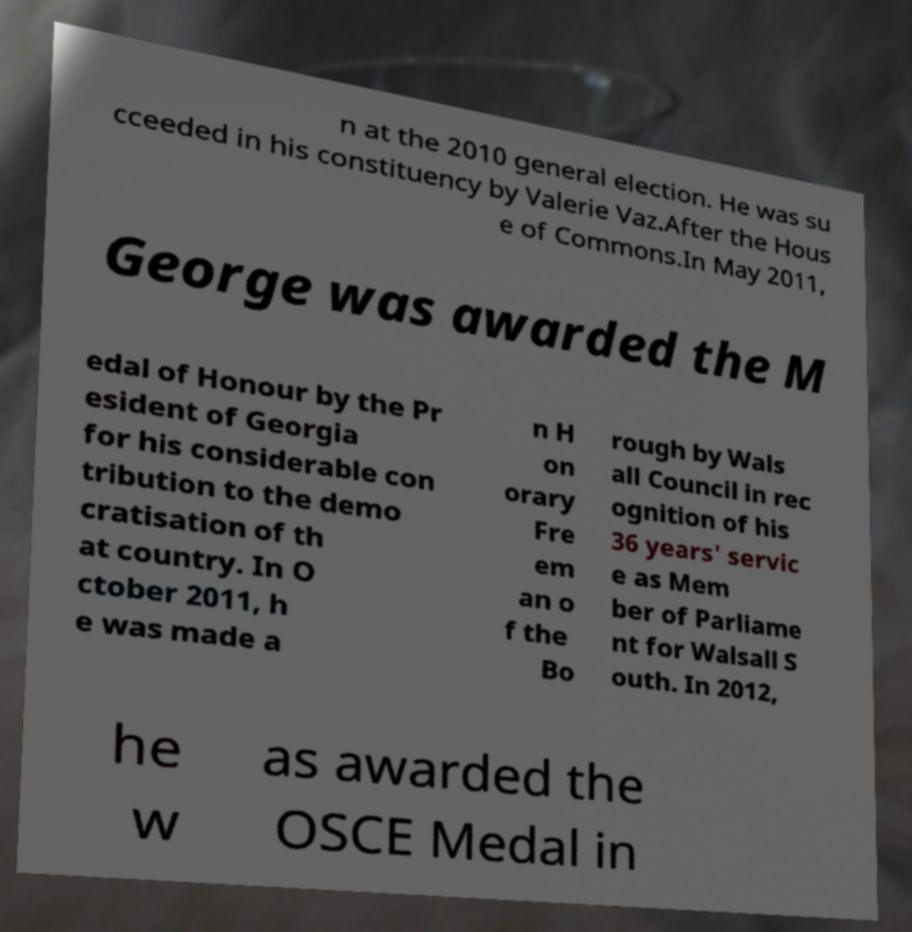There's text embedded in this image that I need extracted. Can you transcribe it verbatim? n at the 2010 general election. He was su cceeded in his constituency by Valerie Vaz.After the Hous e of Commons.In May 2011, George was awarded the M edal of Honour by the Pr esident of Georgia for his considerable con tribution to the demo cratisation of th at country. In O ctober 2011, h e was made a n H on orary Fre em an o f the Bo rough by Wals all Council in rec ognition of his 36 years' servic e as Mem ber of Parliame nt for Walsall S outh. In 2012, he w as awarded the OSCE Medal in 